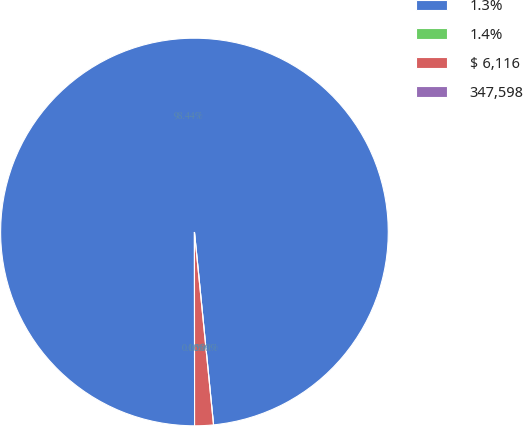Convert chart to OTSL. <chart><loc_0><loc_0><loc_500><loc_500><pie_chart><fcel>1.3%<fcel>1.4%<fcel>$ 6,116<fcel>347,598<nl><fcel>98.44%<fcel>0.0%<fcel>1.56%<fcel>0.0%<nl></chart> 